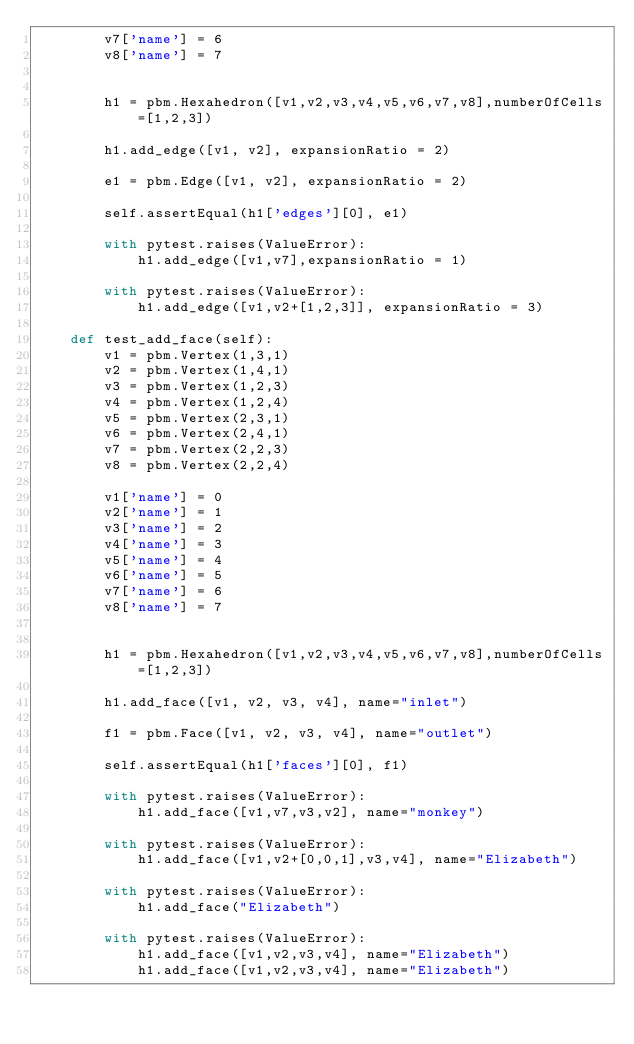Convert code to text. <code><loc_0><loc_0><loc_500><loc_500><_Python_>        v7['name'] = 6
        v8['name'] = 7


        h1 = pbm.Hexahedron([v1,v2,v3,v4,v5,v6,v7,v8],numberOfCells=[1,2,3])

        h1.add_edge([v1, v2], expansionRatio = 2)

        e1 = pbm.Edge([v1, v2], expansionRatio = 2)

        self.assertEqual(h1['edges'][0], e1)

        with pytest.raises(ValueError):
            h1.add_edge([v1,v7],expansionRatio = 1)

        with pytest.raises(ValueError):
            h1.add_edge([v1,v2+[1,2,3]], expansionRatio = 3)

    def test_add_face(self):
        v1 = pbm.Vertex(1,3,1)
        v2 = pbm.Vertex(1,4,1)
        v3 = pbm.Vertex(1,2,3)
        v4 = pbm.Vertex(1,2,4)
        v5 = pbm.Vertex(2,3,1)
        v6 = pbm.Vertex(2,4,1)
        v7 = pbm.Vertex(2,2,3)
        v8 = pbm.Vertex(2,2,4)

        v1['name'] = 0
        v2['name'] = 1
        v3['name'] = 2
        v4['name'] = 3
        v5['name'] = 4
        v6['name'] = 5
        v7['name'] = 6
        v8['name'] = 7


        h1 = pbm.Hexahedron([v1,v2,v3,v4,v5,v6,v7,v8],numberOfCells=[1,2,3])

        h1.add_face([v1, v2, v3, v4], name="inlet")

        f1 = pbm.Face([v1, v2, v3, v4], name="outlet")

        self.assertEqual(h1['faces'][0], f1)

        with pytest.raises(ValueError):
            h1.add_face([v1,v7,v3,v2], name="monkey")

        with pytest.raises(ValueError):
            h1.add_face([v1,v2+[0,0,1],v3,v4], name="Elizabeth")

        with pytest.raises(ValueError):
            h1.add_face("Elizabeth")

        with pytest.raises(ValueError):
            h1.add_face([v1,v2,v3,v4], name="Elizabeth")
            h1.add_face([v1,v2,v3,v4], name="Elizabeth")
</code> 